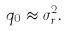Convert formula to latex. <formula><loc_0><loc_0><loc_500><loc_500>q _ { 0 } \approx \sigma _ { r } ^ { 2 } .</formula> 